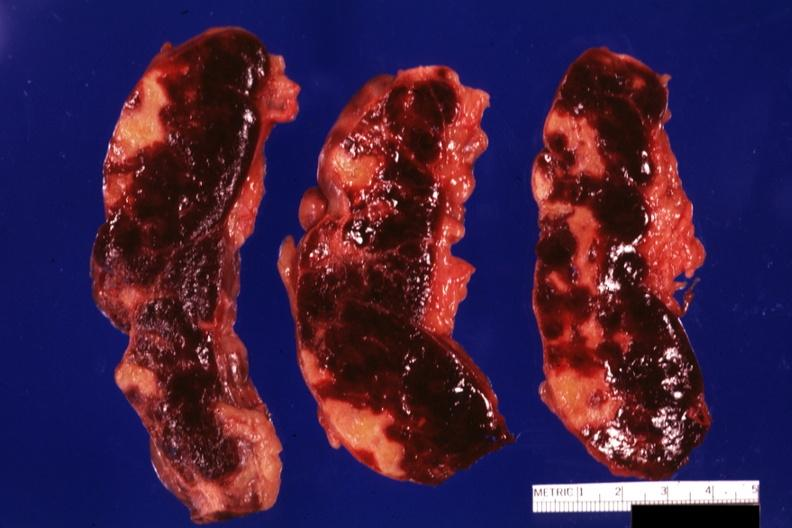what is present?
Answer the question using a single word or phrase. Hematologic 